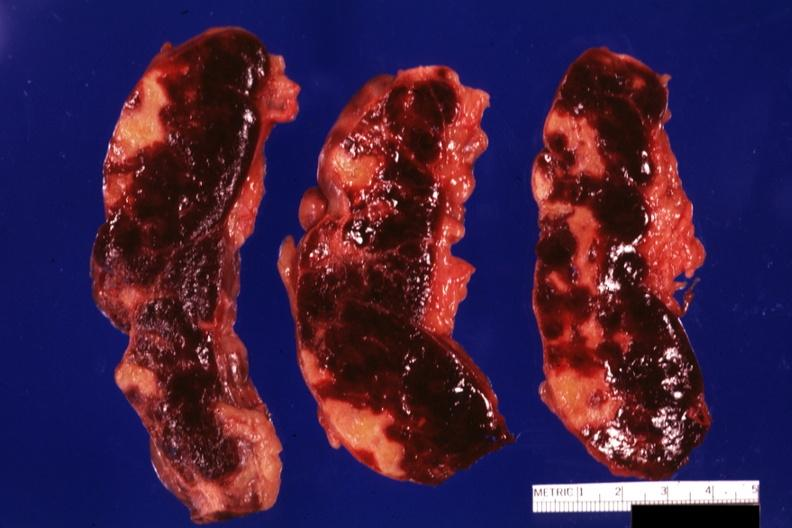what is present?
Answer the question using a single word or phrase. Hematologic 